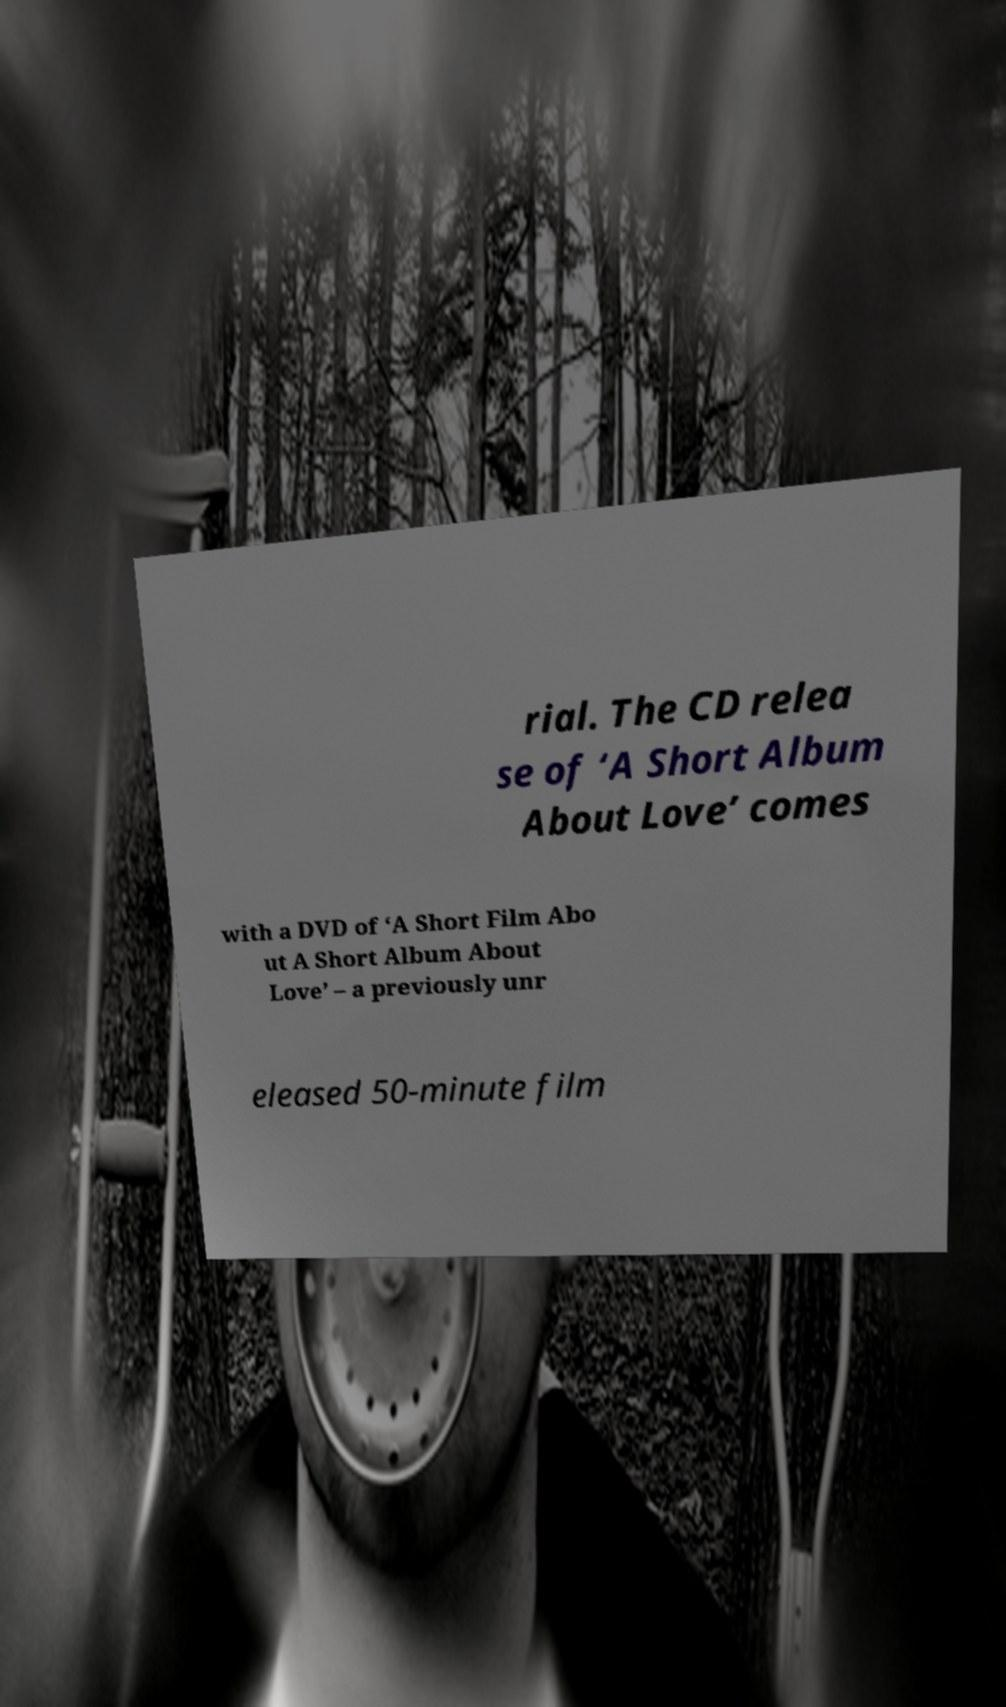Please read and relay the text visible in this image. What does it say? rial. The CD relea se of ‘A Short Album About Love’ comes with a DVD of ‘A Short Film Abo ut A Short Album About Love’ – a previously unr eleased 50-minute film 